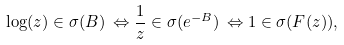<formula> <loc_0><loc_0><loc_500><loc_500>\log ( z ) \in \sigma ( B ) \, \Leftrightarrow \frac { 1 } { z } \in \sigma ( e ^ { - B } ) \, \Leftrightarrow 1 \in \sigma ( F ( z ) ) ,</formula> 